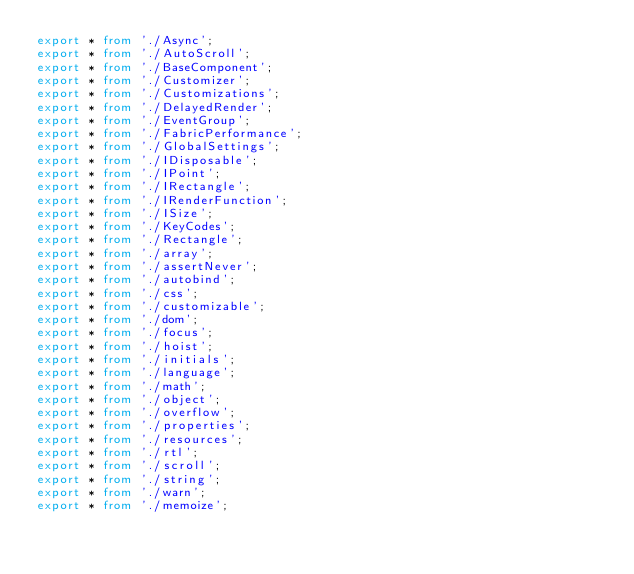<code> <loc_0><loc_0><loc_500><loc_500><_TypeScript_>export * from './Async';
export * from './AutoScroll';
export * from './BaseComponent';
export * from './Customizer';
export * from './Customizations';
export * from './DelayedRender';
export * from './EventGroup';
export * from './FabricPerformance';
export * from './GlobalSettings';
export * from './IDisposable';
export * from './IPoint';
export * from './IRectangle';
export * from './IRenderFunction';
export * from './ISize';
export * from './KeyCodes';
export * from './Rectangle';
export * from './array';
export * from './assertNever';
export * from './autobind';
export * from './css';
export * from './customizable';
export * from './dom';
export * from './focus';
export * from './hoist';
export * from './initials';
export * from './language';
export * from './math';
export * from './object';
export * from './overflow';
export * from './properties';
export * from './resources';
export * from './rtl';
export * from './scroll';
export * from './string';
export * from './warn';
export * from './memoize';
</code> 